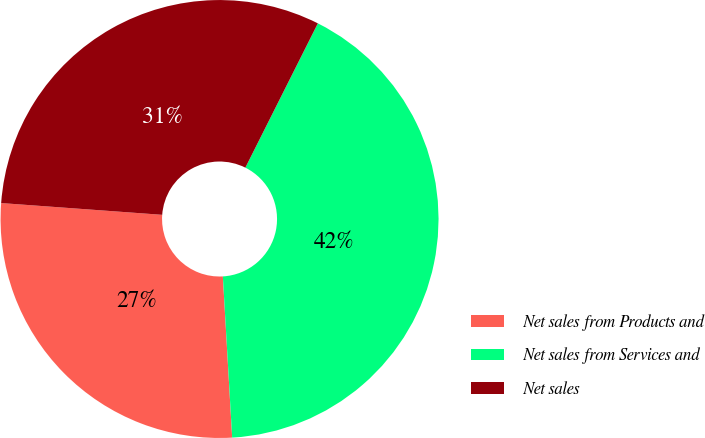Convert chart. <chart><loc_0><loc_0><loc_500><loc_500><pie_chart><fcel>Net sales from Products and<fcel>Net sales from Services and<fcel>Net sales<nl><fcel>27.08%<fcel>41.67%<fcel>31.25%<nl></chart> 